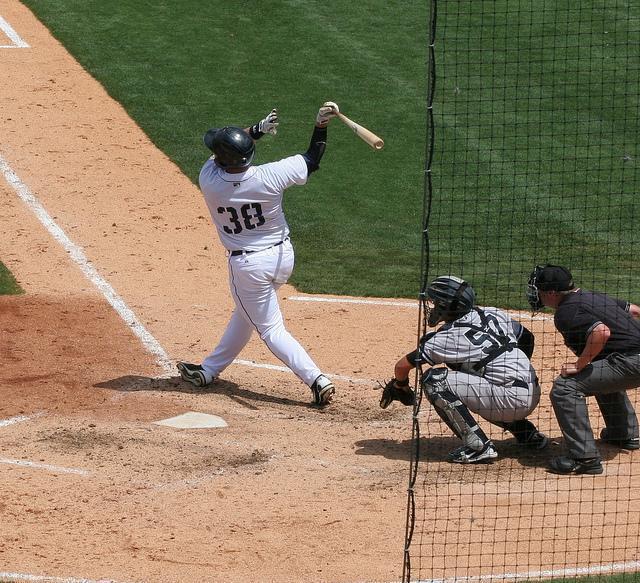How many people are standing up?
Give a very brief answer. 1. How many shoes are visible?
Give a very brief answer. 6. How many people can you see?
Give a very brief answer. 3. How many chairs are standing with the table?
Give a very brief answer. 0. 